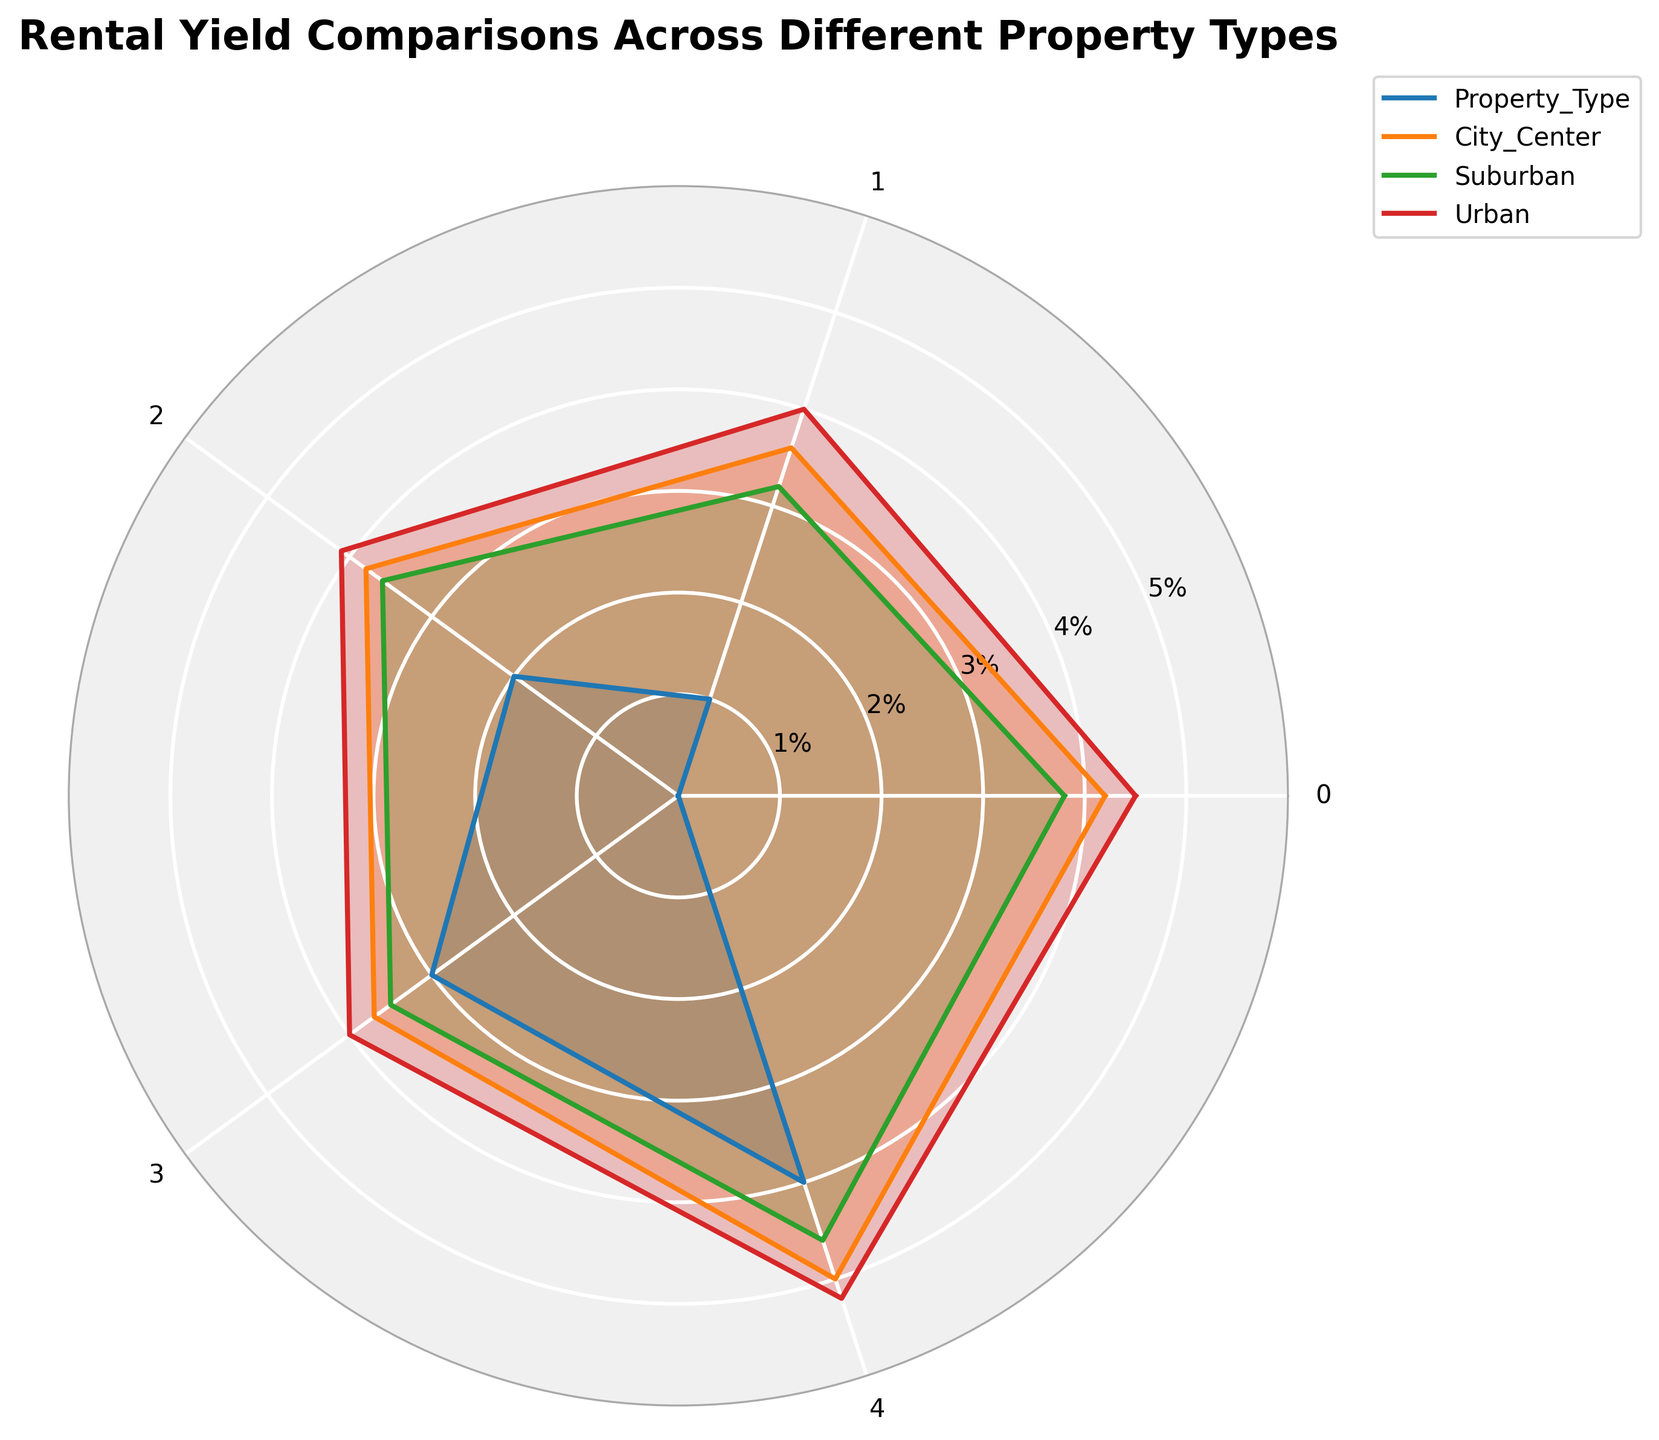What is the rental yield for studios in Urban areas? The rental yield for studios in Urban areas is shown as 5.2% on the radar chart.
Answer: 5.2% What type of property has the highest rental yield in Suburban areas? The highest rental yield in Suburban areas is for Studios, which is 4.6%.
Answer: Studios Which property type has the lowest rental yield in City Center areas? By looking at the City Center yields, the Detached House has the lowest yield at 3.6%.
Answer: Detached House Compare the rental yields of Apartments and Terraced Houses in Urban areas. Which one is higher and by how much? The rental yield for Apartments in Urban areas is 4.5%, and for Terraced Houses, it is 4.0%. The difference is 4.5% - 4.0% = 0.5%.
Answer: Apartments by 0.5% Which property type shows the most consistent rental yield across the three areas (City Center, Suburban, and Urban)? To determine consistency, we observe the rental yields in all areas for each property type. Semi-Detached Houses have yields of 3.8%, 3.6%, and 4.1%, showing the least variation.
Answer: Semi-Detached Houses How does the rental yield of Detached Houses in Urban areas compare to that of City Center areas? The rental yield of Detached Houses in Urban areas is 4.0%, whereas in City Center areas it is 3.6%. The Urban yield is 0.4% higher.
Answer: Urban areas by 0.4% What is the average rental yield for Terraced Houses across all three areas? The rental yields for Terraced Houses are: City Center (3.7%), Suburban (3.5%), and Urban (4.0%). The average yield is (3.7 + 3.5 + 4.0) / 3 = 3.733%.
Answer: 3.733% If you wanted to invest in a property type with a high yield regardless of location, which type should you choose? By examining the highest yields across all property types, Studios have the highest yields in all areas: City Center (5.0%), Suburban (4.6%), and Urban (5.2%).
Answer: Studios 